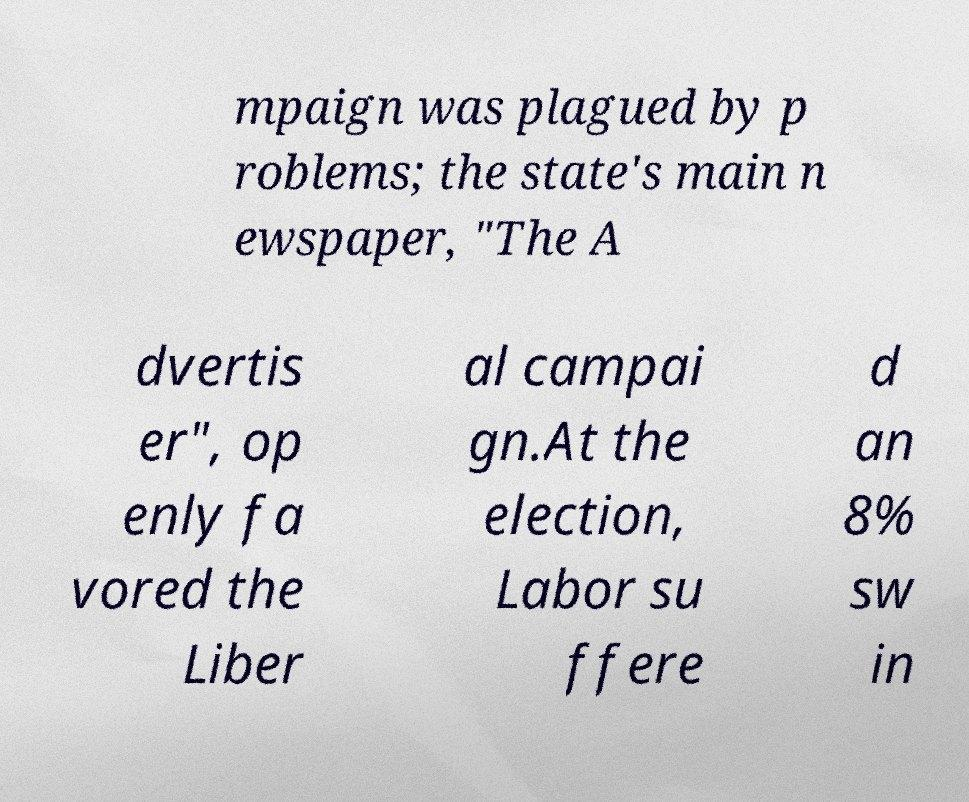There's text embedded in this image that I need extracted. Can you transcribe it verbatim? mpaign was plagued by p roblems; the state's main n ewspaper, "The A dvertis er", op enly fa vored the Liber al campai gn.At the election, Labor su ffere d an 8% sw in 